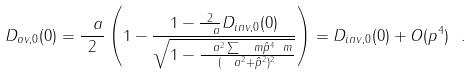Convert formula to latex. <formula><loc_0><loc_0><loc_500><loc_500>D _ { o v , 0 } ( 0 ) = \frac { \ a } { 2 } \left ( 1 - \frac { 1 - \frac { 2 } { \ a } D _ { i n v , 0 } ( 0 ) } { \sqrt { 1 - \frac { \ a ^ { 2 } \sum _ { \ } m \hat { p } ^ { 4 } _ { \ } m } { ( \ a ^ { 2 } + \hat { p } ^ { 2 } ) ^ { 2 } } } } \right ) = D _ { i n v , 0 } ( 0 ) + O ( p ^ { 4 } ) \ .</formula> 